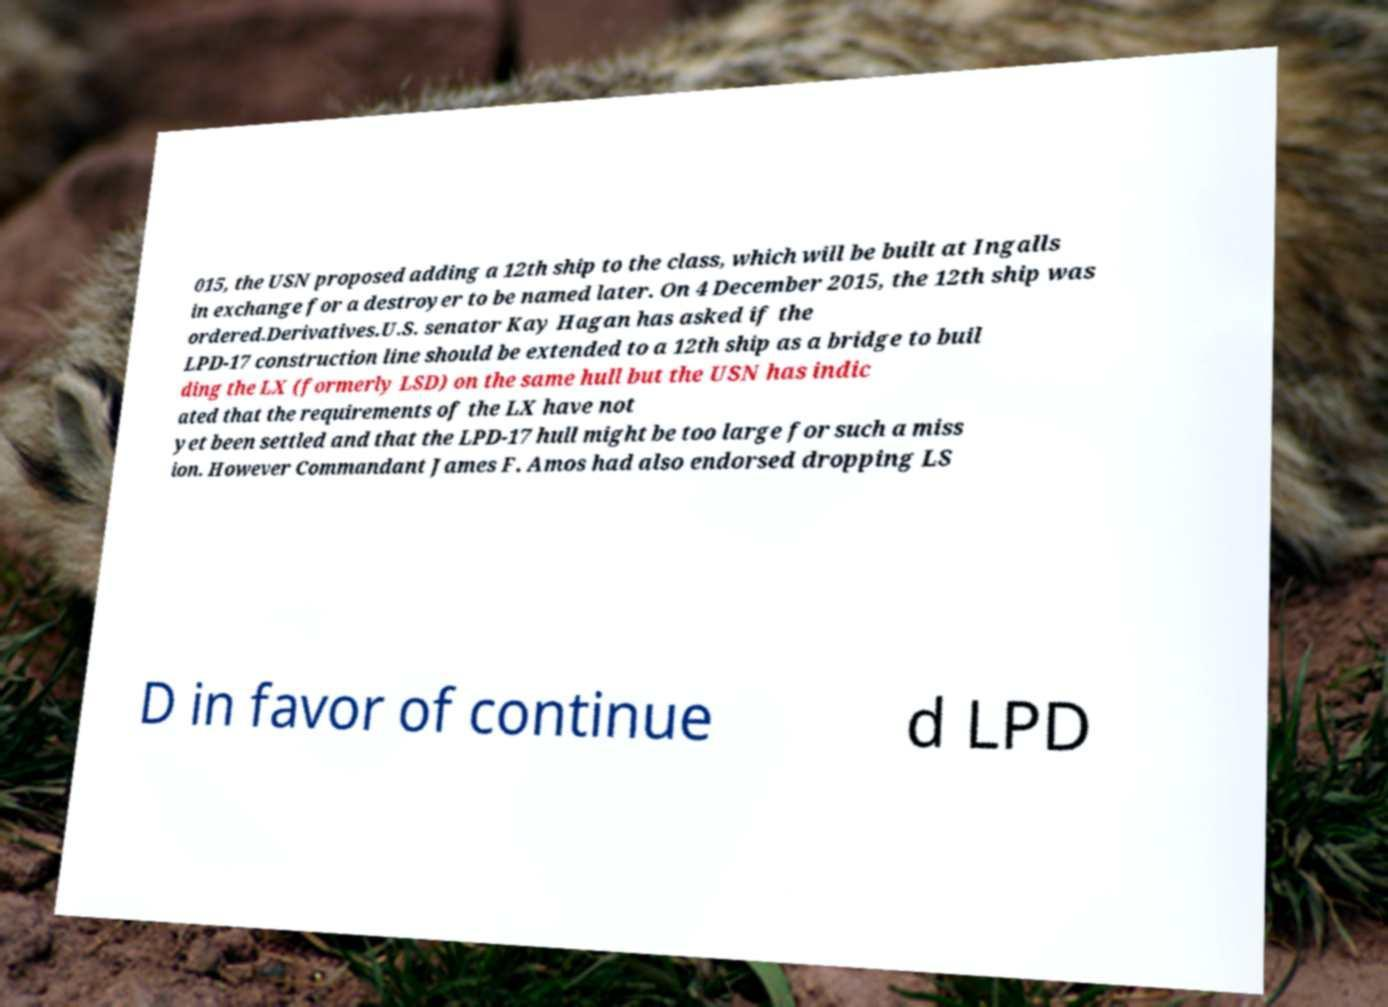There's text embedded in this image that I need extracted. Can you transcribe it verbatim? 015, the USN proposed adding a 12th ship to the class, which will be built at Ingalls in exchange for a destroyer to be named later. On 4 December 2015, the 12th ship was ordered.Derivatives.U.S. senator Kay Hagan has asked if the LPD-17 construction line should be extended to a 12th ship as a bridge to buil ding the LX (formerly LSD) on the same hull but the USN has indic ated that the requirements of the LX have not yet been settled and that the LPD-17 hull might be too large for such a miss ion. However Commandant James F. Amos had also endorsed dropping LS D in favor of continue d LPD 